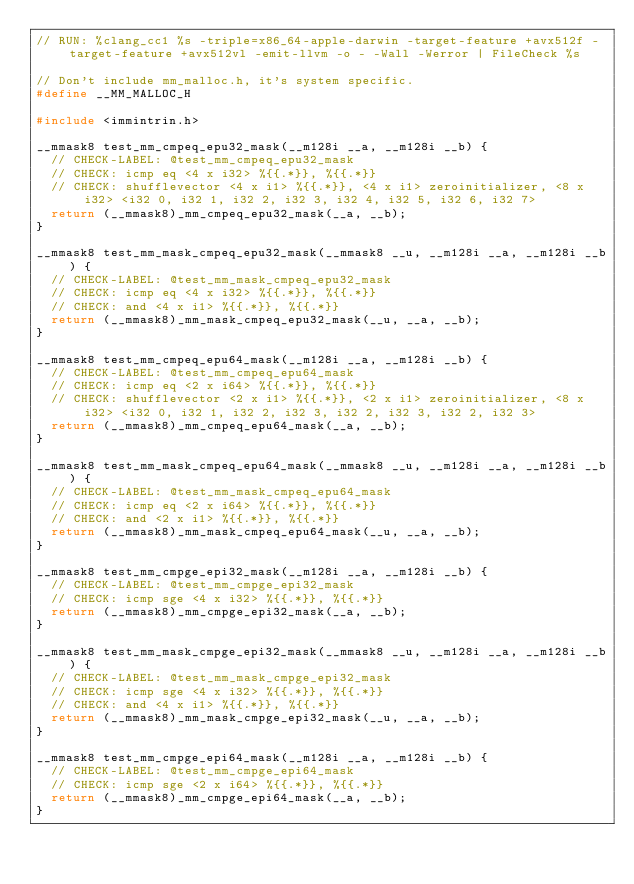<code> <loc_0><loc_0><loc_500><loc_500><_C_>// RUN: %clang_cc1 %s -triple=x86_64-apple-darwin -target-feature +avx512f -target-feature +avx512vl -emit-llvm -o - -Wall -Werror | FileCheck %s

// Don't include mm_malloc.h, it's system specific.
#define __MM_MALLOC_H

#include <immintrin.h>

__mmask8 test_mm_cmpeq_epu32_mask(__m128i __a, __m128i __b) {
  // CHECK-LABEL: @test_mm_cmpeq_epu32_mask
  // CHECK: icmp eq <4 x i32> %{{.*}}, %{{.*}}
  // CHECK: shufflevector <4 x i1> %{{.*}}, <4 x i1> zeroinitializer, <8 x i32> <i32 0, i32 1, i32 2, i32 3, i32 4, i32 5, i32 6, i32 7>
  return (__mmask8)_mm_cmpeq_epu32_mask(__a, __b);
}

__mmask8 test_mm_mask_cmpeq_epu32_mask(__mmask8 __u, __m128i __a, __m128i __b) {
  // CHECK-LABEL: @test_mm_mask_cmpeq_epu32_mask
  // CHECK: icmp eq <4 x i32> %{{.*}}, %{{.*}}
  // CHECK: and <4 x i1> %{{.*}}, %{{.*}}
  return (__mmask8)_mm_mask_cmpeq_epu32_mask(__u, __a, __b);
}

__mmask8 test_mm_cmpeq_epu64_mask(__m128i __a, __m128i __b) {
  // CHECK-LABEL: @test_mm_cmpeq_epu64_mask
  // CHECK: icmp eq <2 x i64> %{{.*}}, %{{.*}}
  // CHECK: shufflevector <2 x i1> %{{.*}}, <2 x i1> zeroinitializer, <8 x i32> <i32 0, i32 1, i32 2, i32 3, i32 2, i32 3, i32 2, i32 3>
  return (__mmask8)_mm_cmpeq_epu64_mask(__a, __b);
}

__mmask8 test_mm_mask_cmpeq_epu64_mask(__mmask8 __u, __m128i __a, __m128i __b) {
  // CHECK-LABEL: @test_mm_mask_cmpeq_epu64_mask
  // CHECK: icmp eq <2 x i64> %{{.*}}, %{{.*}}
  // CHECK: and <2 x i1> %{{.*}}, %{{.*}}
  return (__mmask8)_mm_mask_cmpeq_epu64_mask(__u, __a, __b);
}

__mmask8 test_mm_cmpge_epi32_mask(__m128i __a, __m128i __b) {
  // CHECK-LABEL: @test_mm_cmpge_epi32_mask
  // CHECK: icmp sge <4 x i32> %{{.*}}, %{{.*}}
  return (__mmask8)_mm_cmpge_epi32_mask(__a, __b);
}

__mmask8 test_mm_mask_cmpge_epi32_mask(__mmask8 __u, __m128i __a, __m128i __b) {
  // CHECK-LABEL: @test_mm_mask_cmpge_epi32_mask
  // CHECK: icmp sge <4 x i32> %{{.*}}, %{{.*}}
  // CHECK: and <4 x i1> %{{.*}}, %{{.*}}
  return (__mmask8)_mm_mask_cmpge_epi32_mask(__u, __a, __b);
}

__mmask8 test_mm_cmpge_epi64_mask(__m128i __a, __m128i __b) {
  // CHECK-LABEL: @test_mm_cmpge_epi64_mask
  // CHECK: icmp sge <2 x i64> %{{.*}}, %{{.*}}
  return (__mmask8)_mm_cmpge_epi64_mask(__a, __b);
}
</code> 